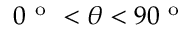Convert formula to latex. <formula><loc_0><loc_0><loc_500><loc_500>0 ^ { o } < \theta < 9 0 ^ { o }</formula> 